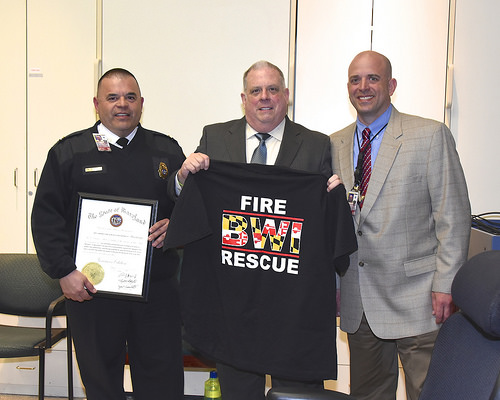<image>
Can you confirm if the man is on the t shirt? Yes. Looking at the image, I can see the man is positioned on top of the t shirt, with the t shirt providing support. Is the tie on the man? Yes. Looking at the image, I can see the tie is positioned on top of the man, with the man providing support. Where is the man in relation to the shirt? Is it behind the shirt? Yes. From this viewpoint, the man is positioned behind the shirt, with the shirt partially or fully occluding the man. 